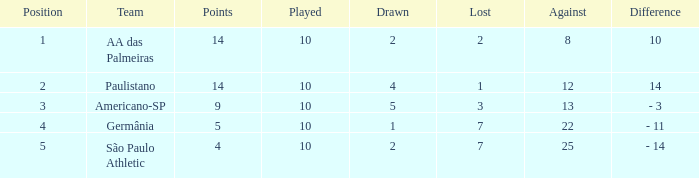What is the smallest against when the played surpasses 10? None. 